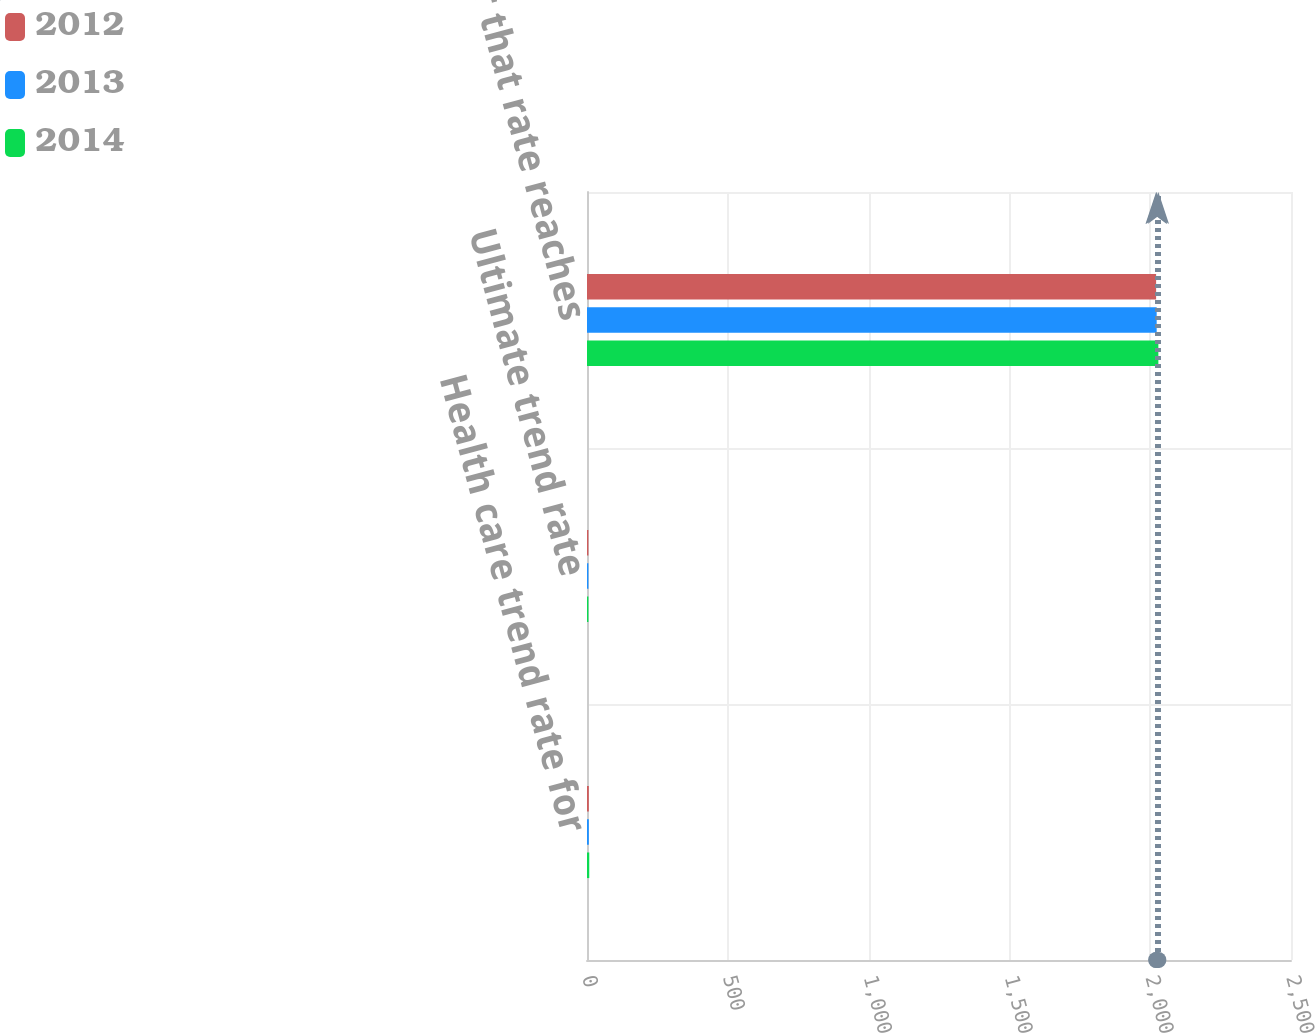Convert chart. <chart><loc_0><loc_0><loc_500><loc_500><stacked_bar_chart><ecel><fcel>Health care trend rate for<fcel>Ultimate trend rate<fcel>Year that rate reaches<nl><fcel>2012<fcel>6.5<fcel>5<fcel>2021<nl><fcel>2013<fcel>6.5<fcel>5<fcel>2023<nl><fcel>2014<fcel>8<fcel>5<fcel>2029<nl></chart> 